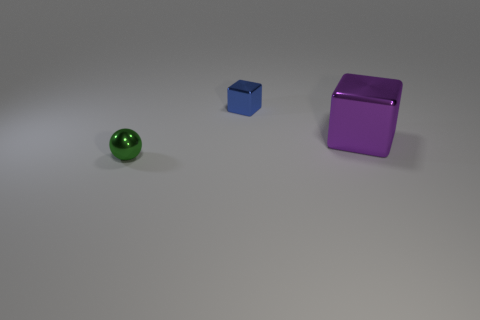Subtract all balls. How many objects are left? 2 Subtract 1 cubes. How many cubes are left? 1 Subtract all blue blocks. Subtract all red balls. How many blocks are left? 1 Subtract all yellow cylinders. How many purple spheres are left? 0 Subtract all green metallic balls. Subtract all big objects. How many objects are left? 1 Add 1 green things. How many green things are left? 2 Add 3 tiny blue objects. How many tiny blue objects exist? 4 Add 3 tiny blue metallic cylinders. How many objects exist? 6 Subtract 0 purple cylinders. How many objects are left? 3 